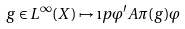<formula> <loc_0><loc_0><loc_500><loc_500>g \in L ^ { \infty } ( X ) \mapsto \i p { \varphi ^ { \prime } } { A \pi ( g ) \varphi }</formula> 